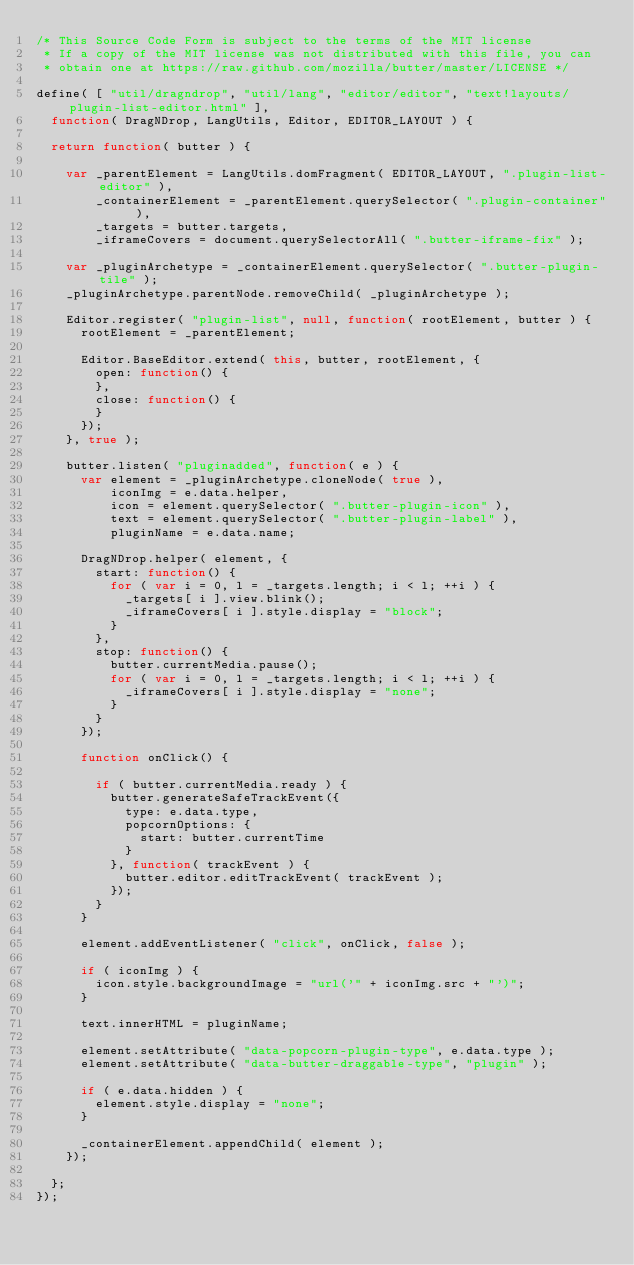<code> <loc_0><loc_0><loc_500><loc_500><_JavaScript_>/* This Source Code Form is subject to the terms of the MIT license
 * If a copy of the MIT license was not distributed with this file, you can
 * obtain one at https://raw.github.com/mozilla/butter/master/LICENSE */

define( [ "util/dragndrop", "util/lang", "editor/editor", "text!layouts/plugin-list-editor.html" ],
  function( DragNDrop, LangUtils, Editor, EDITOR_LAYOUT ) {

  return function( butter ) {

    var _parentElement = LangUtils.domFragment( EDITOR_LAYOUT, ".plugin-list-editor" ),
        _containerElement = _parentElement.querySelector( ".plugin-container" ),
        _targets = butter.targets,
        _iframeCovers = document.querySelectorAll( ".butter-iframe-fix" );

    var _pluginArchetype = _containerElement.querySelector( ".butter-plugin-tile" );
    _pluginArchetype.parentNode.removeChild( _pluginArchetype );

    Editor.register( "plugin-list", null, function( rootElement, butter ) {
      rootElement = _parentElement;

      Editor.BaseEditor.extend( this, butter, rootElement, {
        open: function() {
        },
        close: function() {
        }
      });
    }, true );

    butter.listen( "pluginadded", function( e ) {
      var element = _pluginArchetype.cloneNode( true ),
          iconImg = e.data.helper,
          icon = element.querySelector( ".butter-plugin-icon" ),
          text = element.querySelector( ".butter-plugin-label" ),
          pluginName = e.data.name;

      DragNDrop.helper( element, {
        start: function() {
          for ( var i = 0, l = _targets.length; i < l; ++i ) {
            _targets[ i ].view.blink();
            _iframeCovers[ i ].style.display = "block";
          }
        },
        stop: function() {
          butter.currentMedia.pause();
          for ( var i = 0, l = _targets.length; i < l; ++i ) {
            _iframeCovers[ i ].style.display = "none";
          }
        }
      });

      function onClick() {

        if ( butter.currentMedia.ready ) {
          butter.generateSafeTrackEvent({
            type: e.data.type,
            popcornOptions: {
              start: butter.currentTime
            }
          }, function( trackEvent ) {
            butter.editor.editTrackEvent( trackEvent );
          });
        }
      }

      element.addEventListener( "click", onClick, false );

      if ( iconImg ) {
        icon.style.backgroundImage = "url('" + iconImg.src + "')";
      }

      text.innerHTML = pluginName;

      element.setAttribute( "data-popcorn-plugin-type", e.data.type );
      element.setAttribute( "data-butter-draggable-type", "plugin" );

      if ( e.data.hidden ) {
        element.style.display = "none";
      }

      _containerElement.appendChild( element );
    });

  };
});
</code> 